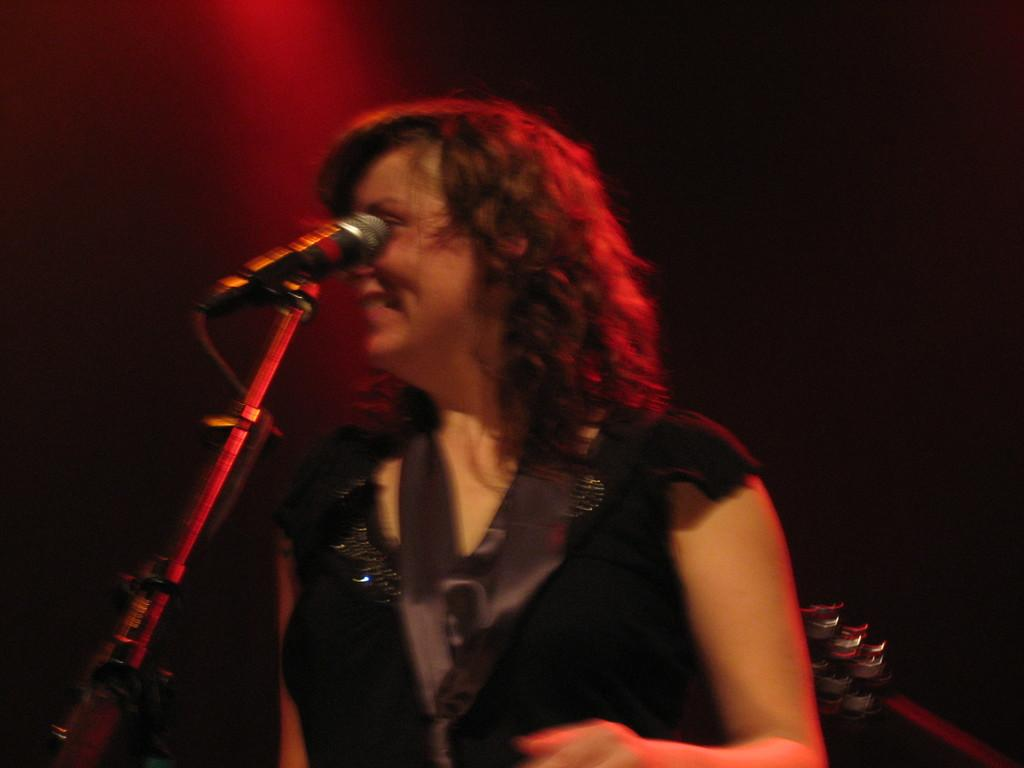Who is the main subject in the image? The main subject in the image is a woman. What is the woman doing in the image? The woman is standing near a microphone. What is the woman's facial expression in the image? The woman is smiling in the image. What is the woman wearing in the image? The woman is wearing a black dress in the image. What can be seen in terms of lighting in the image? There is a red color light focused on the woman in the image. Who is the owner of the basketball in the image? There is no basketball present in the image. 